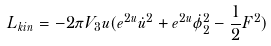<formula> <loc_0><loc_0><loc_500><loc_500>L _ { k i n } = - 2 \pi V _ { 3 } u ( e ^ { 2 u } \dot { u } ^ { 2 } + e ^ { 2 u } \dot { \phi } _ { 2 } ^ { 2 } - \frac { 1 } { 2 } F ^ { 2 } )</formula> 